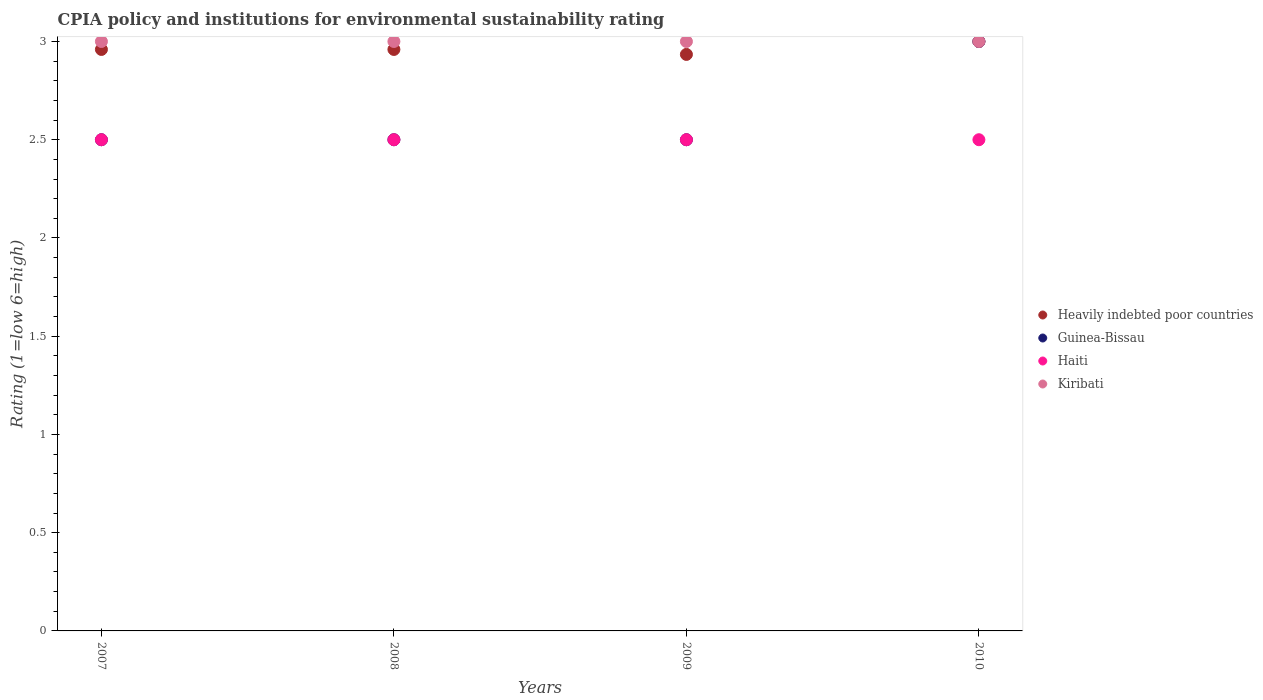Is the number of dotlines equal to the number of legend labels?
Your answer should be very brief. Yes. What is the CPIA rating in Kiribati in 2010?
Provide a short and direct response. 3. Across all years, what is the maximum CPIA rating in Haiti?
Make the answer very short. 2.5. Across all years, what is the minimum CPIA rating in Kiribati?
Keep it short and to the point. 3. In which year was the CPIA rating in Heavily indebted poor countries minimum?
Your response must be concise. 2009. What is the difference between the CPIA rating in Heavily indebted poor countries in 2007 and that in 2010?
Your answer should be compact. -0.04. What is the difference between the CPIA rating in Heavily indebted poor countries in 2007 and the CPIA rating in Kiribati in 2009?
Your answer should be compact. -0.04. What is the average CPIA rating in Guinea-Bissau per year?
Keep it short and to the point. 2.62. In the year 2010, what is the difference between the CPIA rating in Haiti and CPIA rating in Heavily indebted poor countries?
Make the answer very short. -0.5. In how many years, is the CPIA rating in Haiti greater than 0.5?
Your response must be concise. 4. What is the ratio of the CPIA rating in Guinea-Bissau in 2008 to that in 2009?
Your answer should be compact. 1. What is the difference between the highest and the second highest CPIA rating in Guinea-Bissau?
Your answer should be very brief. 0.5. What is the difference between the highest and the lowest CPIA rating in Guinea-Bissau?
Ensure brevity in your answer.  0.5. In how many years, is the CPIA rating in Heavily indebted poor countries greater than the average CPIA rating in Heavily indebted poor countries taken over all years?
Make the answer very short. 1. Is it the case that in every year, the sum of the CPIA rating in Guinea-Bissau and CPIA rating in Kiribati  is greater than the sum of CPIA rating in Heavily indebted poor countries and CPIA rating in Haiti?
Give a very brief answer. No. Does the CPIA rating in Guinea-Bissau monotonically increase over the years?
Ensure brevity in your answer.  No. Is the CPIA rating in Guinea-Bissau strictly less than the CPIA rating in Haiti over the years?
Offer a very short reply. No. Does the graph contain grids?
Your answer should be very brief. No. Where does the legend appear in the graph?
Your response must be concise. Center right. What is the title of the graph?
Keep it short and to the point. CPIA policy and institutions for environmental sustainability rating. Does "Bahamas" appear as one of the legend labels in the graph?
Ensure brevity in your answer.  No. What is the label or title of the X-axis?
Provide a short and direct response. Years. What is the Rating (1=low 6=high) of Heavily indebted poor countries in 2007?
Your answer should be compact. 2.96. What is the Rating (1=low 6=high) of Guinea-Bissau in 2007?
Offer a terse response. 2.5. What is the Rating (1=low 6=high) in Haiti in 2007?
Provide a succinct answer. 2.5. What is the Rating (1=low 6=high) of Kiribati in 2007?
Ensure brevity in your answer.  3. What is the Rating (1=low 6=high) of Heavily indebted poor countries in 2008?
Make the answer very short. 2.96. What is the Rating (1=low 6=high) of Heavily indebted poor countries in 2009?
Keep it short and to the point. 2.93. What is the Rating (1=low 6=high) of Guinea-Bissau in 2009?
Keep it short and to the point. 2.5. What is the Rating (1=low 6=high) in Haiti in 2009?
Offer a very short reply. 2.5. What is the Rating (1=low 6=high) in Kiribati in 2009?
Keep it short and to the point. 3. What is the Rating (1=low 6=high) of Haiti in 2010?
Your response must be concise. 2.5. Across all years, what is the minimum Rating (1=low 6=high) of Heavily indebted poor countries?
Provide a short and direct response. 2.93. Across all years, what is the minimum Rating (1=low 6=high) of Haiti?
Give a very brief answer. 2.5. What is the total Rating (1=low 6=high) in Heavily indebted poor countries in the graph?
Ensure brevity in your answer.  11.85. What is the total Rating (1=low 6=high) of Haiti in the graph?
Your answer should be very brief. 10. What is the total Rating (1=low 6=high) in Kiribati in the graph?
Ensure brevity in your answer.  12. What is the difference between the Rating (1=low 6=high) of Heavily indebted poor countries in 2007 and that in 2008?
Provide a succinct answer. 0. What is the difference between the Rating (1=low 6=high) of Haiti in 2007 and that in 2008?
Offer a terse response. 0. What is the difference between the Rating (1=low 6=high) of Heavily indebted poor countries in 2007 and that in 2009?
Ensure brevity in your answer.  0.03. What is the difference between the Rating (1=low 6=high) of Heavily indebted poor countries in 2007 and that in 2010?
Ensure brevity in your answer.  -0.04. What is the difference between the Rating (1=low 6=high) of Kiribati in 2007 and that in 2010?
Keep it short and to the point. 0. What is the difference between the Rating (1=low 6=high) of Heavily indebted poor countries in 2008 and that in 2009?
Your response must be concise. 0.03. What is the difference between the Rating (1=low 6=high) in Haiti in 2008 and that in 2009?
Offer a terse response. 0. What is the difference between the Rating (1=low 6=high) in Kiribati in 2008 and that in 2009?
Provide a succinct answer. 0. What is the difference between the Rating (1=low 6=high) of Heavily indebted poor countries in 2008 and that in 2010?
Keep it short and to the point. -0.04. What is the difference between the Rating (1=low 6=high) in Guinea-Bissau in 2008 and that in 2010?
Your response must be concise. -0.5. What is the difference between the Rating (1=low 6=high) in Haiti in 2008 and that in 2010?
Give a very brief answer. 0. What is the difference between the Rating (1=low 6=high) of Heavily indebted poor countries in 2009 and that in 2010?
Your answer should be very brief. -0.07. What is the difference between the Rating (1=low 6=high) in Guinea-Bissau in 2009 and that in 2010?
Your answer should be very brief. -0.5. What is the difference between the Rating (1=low 6=high) of Haiti in 2009 and that in 2010?
Provide a short and direct response. 0. What is the difference between the Rating (1=low 6=high) of Kiribati in 2009 and that in 2010?
Provide a short and direct response. 0. What is the difference between the Rating (1=low 6=high) of Heavily indebted poor countries in 2007 and the Rating (1=low 6=high) of Guinea-Bissau in 2008?
Give a very brief answer. 0.46. What is the difference between the Rating (1=low 6=high) in Heavily indebted poor countries in 2007 and the Rating (1=low 6=high) in Haiti in 2008?
Your response must be concise. 0.46. What is the difference between the Rating (1=low 6=high) in Heavily indebted poor countries in 2007 and the Rating (1=low 6=high) in Kiribati in 2008?
Offer a very short reply. -0.04. What is the difference between the Rating (1=low 6=high) of Haiti in 2007 and the Rating (1=low 6=high) of Kiribati in 2008?
Your answer should be very brief. -0.5. What is the difference between the Rating (1=low 6=high) in Heavily indebted poor countries in 2007 and the Rating (1=low 6=high) in Guinea-Bissau in 2009?
Ensure brevity in your answer.  0.46. What is the difference between the Rating (1=low 6=high) of Heavily indebted poor countries in 2007 and the Rating (1=low 6=high) of Haiti in 2009?
Provide a short and direct response. 0.46. What is the difference between the Rating (1=low 6=high) in Heavily indebted poor countries in 2007 and the Rating (1=low 6=high) in Kiribati in 2009?
Your answer should be compact. -0.04. What is the difference between the Rating (1=low 6=high) in Guinea-Bissau in 2007 and the Rating (1=low 6=high) in Haiti in 2009?
Provide a succinct answer. 0. What is the difference between the Rating (1=low 6=high) in Heavily indebted poor countries in 2007 and the Rating (1=low 6=high) in Guinea-Bissau in 2010?
Offer a terse response. -0.04. What is the difference between the Rating (1=low 6=high) in Heavily indebted poor countries in 2007 and the Rating (1=low 6=high) in Haiti in 2010?
Keep it short and to the point. 0.46. What is the difference between the Rating (1=low 6=high) of Heavily indebted poor countries in 2007 and the Rating (1=low 6=high) of Kiribati in 2010?
Offer a very short reply. -0.04. What is the difference between the Rating (1=low 6=high) in Guinea-Bissau in 2007 and the Rating (1=low 6=high) in Haiti in 2010?
Make the answer very short. 0. What is the difference between the Rating (1=low 6=high) in Haiti in 2007 and the Rating (1=low 6=high) in Kiribati in 2010?
Give a very brief answer. -0.5. What is the difference between the Rating (1=low 6=high) in Heavily indebted poor countries in 2008 and the Rating (1=low 6=high) in Guinea-Bissau in 2009?
Your answer should be very brief. 0.46. What is the difference between the Rating (1=low 6=high) of Heavily indebted poor countries in 2008 and the Rating (1=low 6=high) of Haiti in 2009?
Offer a terse response. 0.46. What is the difference between the Rating (1=low 6=high) of Heavily indebted poor countries in 2008 and the Rating (1=low 6=high) of Kiribati in 2009?
Provide a succinct answer. -0.04. What is the difference between the Rating (1=low 6=high) in Guinea-Bissau in 2008 and the Rating (1=low 6=high) in Haiti in 2009?
Offer a terse response. 0. What is the difference between the Rating (1=low 6=high) in Haiti in 2008 and the Rating (1=low 6=high) in Kiribati in 2009?
Your answer should be compact. -0.5. What is the difference between the Rating (1=low 6=high) of Heavily indebted poor countries in 2008 and the Rating (1=low 6=high) of Guinea-Bissau in 2010?
Offer a terse response. -0.04. What is the difference between the Rating (1=low 6=high) of Heavily indebted poor countries in 2008 and the Rating (1=low 6=high) of Haiti in 2010?
Offer a very short reply. 0.46. What is the difference between the Rating (1=low 6=high) of Heavily indebted poor countries in 2008 and the Rating (1=low 6=high) of Kiribati in 2010?
Your response must be concise. -0.04. What is the difference between the Rating (1=low 6=high) in Guinea-Bissau in 2008 and the Rating (1=low 6=high) in Haiti in 2010?
Provide a succinct answer. 0. What is the difference between the Rating (1=low 6=high) in Guinea-Bissau in 2008 and the Rating (1=low 6=high) in Kiribati in 2010?
Provide a succinct answer. -0.5. What is the difference between the Rating (1=low 6=high) of Haiti in 2008 and the Rating (1=low 6=high) of Kiribati in 2010?
Make the answer very short. -0.5. What is the difference between the Rating (1=low 6=high) of Heavily indebted poor countries in 2009 and the Rating (1=low 6=high) of Guinea-Bissau in 2010?
Your answer should be compact. -0.07. What is the difference between the Rating (1=low 6=high) of Heavily indebted poor countries in 2009 and the Rating (1=low 6=high) of Haiti in 2010?
Your response must be concise. 0.43. What is the difference between the Rating (1=low 6=high) in Heavily indebted poor countries in 2009 and the Rating (1=low 6=high) in Kiribati in 2010?
Offer a terse response. -0.07. What is the difference between the Rating (1=low 6=high) of Haiti in 2009 and the Rating (1=low 6=high) of Kiribati in 2010?
Give a very brief answer. -0.5. What is the average Rating (1=low 6=high) of Heavily indebted poor countries per year?
Keep it short and to the point. 2.96. What is the average Rating (1=low 6=high) in Guinea-Bissau per year?
Your answer should be very brief. 2.62. What is the average Rating (1=low 6=high) of Haiti per year?
Offer a very short reply. 2.5. In the year 2007, what is the difference between the Rating (1=low 6=high) in Heavily indebted poor countries and Rating (1=low 6=high) in Guinea-Bissau?
Your answer should be compact. 0.46. In the year 2007, what is the difference between the Rating (1=low 6=high) of Heavily indebted poor countries and Rating (1=low 6=high) of Haiti?
Ensure brevity in your answer.  0.46. In the year 2007, what is the difference between the Rating (1=low 6=high) in Heavily indebted poor countries and Rating (1=low 6=high) in Kiribati?
Make the answer very short. -0.04. In the year 2007, what is the difference between the Rating (1=low 6=high) in Guinea-Bissau and Rating (1=low 6=high) in Kiribati?
Ensure brevity in your answer.  -0.5. In the year 2008, what is the difference between the Rating (1=low 6=high) of Heavily indebted poor countries and Rating (1=low 6=high) of Guinea-Bissau?
Provide a succinct answer. 0.46. In the year 2008, what is the difference between the Rating (1=low 6=high) of Heavily indebted poor countries and Rating (1=low 6=high) of Haiti?
Provide a short and direct response. 0.46. In the year 2008, what is the difference between the Rating (1=low 6=high) in Heavily indebted poor countries and Rating (1=low 6=high) in Kiribati?
Offer a very short reply. -0.04. In the year 2008, what is the difference between the Rating (1=low 6=high) in Haiti and Rating (1=low 6=high) in Kiribati?
Offer a terse response. -0.5. In the year 2009, what is the difference between the Rating (1=low 6=high) in Heavily indebted poor countries and Rating (1=low 6=high) in Guinea-Bissau?
Your response must be concise. 0.43. In the year 2009, what is the difference between the Rating (1=low 6=high) in Heavily indebted poor countries and Rating (1=low 6=high) in Haiti?
Your answer should be compact. 0.43. In the year 2009, what is the difference between the Rating (1=low 6=high) in Heavily indebted poor countries and Rating (1=low 6=high) in Kiribati?
Offer a terse response. -0.07. In the year 2009, what is the difference between the Rating (1=low 6=high) in Guinea-Bissau and Rating (1=low 6=high) in Haiti?
Your answer should be compact. 0. In the year 2009, what is the difference between the Rating (1=low 6=high) in Guinea-Bissau and Rating (1=low 6=high) in Kiribati?
Offer a very short reply. -0.5. In the year 2010, what is the difference between the Rating (1=low 6=high) of Heavily indebted poor countries and Rating (1=low 6=high) of Guinea-Bissau?
Your answer should be very brief. 0. In the year 2010, what is the difference between the Rating (1=low 6=high) of Heavily indebted poor countries and Rating (1=low 6=high) of Kiribati?
Keep it short and to the point. 0. What is the ratio of the Rating (1=low 6=high) of Heavily indebted poor countries in 2007 to that in 2008?
Ensure brevity in your answer.  1. What is the ratio of the Rating (1=low 6=high) in Heavily indebted poor countries in 2007 to that in 2009?
Your answer should be very brief. 1.01. What is the ratio of the Rating (1=low 6=high) of Kiribati in 2007 to that in 2009?
Your answer should be very brief. 1. What is the ratio of the Rating (1=low 6=high) of Heavily indebted poor countries in 2007 to that in 2010?
Make the answer very short. 0.99. What is the ratio of the Rating (1=low 6=high) in Guinea-Bissau in 2007 to that in 2010?
Provide a short and direct response. 0.83. What is the ratio of the Rating (1=low 6=high) in Heavily indebted poor countries in 2008 to that in 2009?
Ensure brevity in your answer.  1.01. What is the ratio of the Rating (1=low 6=high) in Haiti in 2008 to that in 2009?
Give a very brief answer. 1. What is the ratio of the Rating (1=low 6=high) of Heavily indebted poor countries in 2008 to that in 2010?
Your response must be concise. 0.99. What is the ratio of the Rating (1=low 6=high) of Heavily indebted poor countries in 2009 to that in 2010?
Your response must be concise. 0.98. What is the ratio of the Rating (1=low 6=high) of Guinea-Bissau in 2009 to that in 2010?
Provide a succinct answer. 0.83. What is the ratio of the Rating (1=low 6=high) of Kiribati in 2009 to that in 2010?
Provide a short and direct response. 1. What is the difference between the highest and the second highest Rating (1=low 6=high) of Heavily indebted poor countries?
Your answer should be compact. 0.04. What is the difference between the highest and the second highest Rating (1=low 6=high) of Kiribati?
Make the answer very short. 0. What is the difference between the highest and the lowest Rating (1=low 6=high) in Heavily indebted poor countries?
Offer a very short reply. 0.07. 